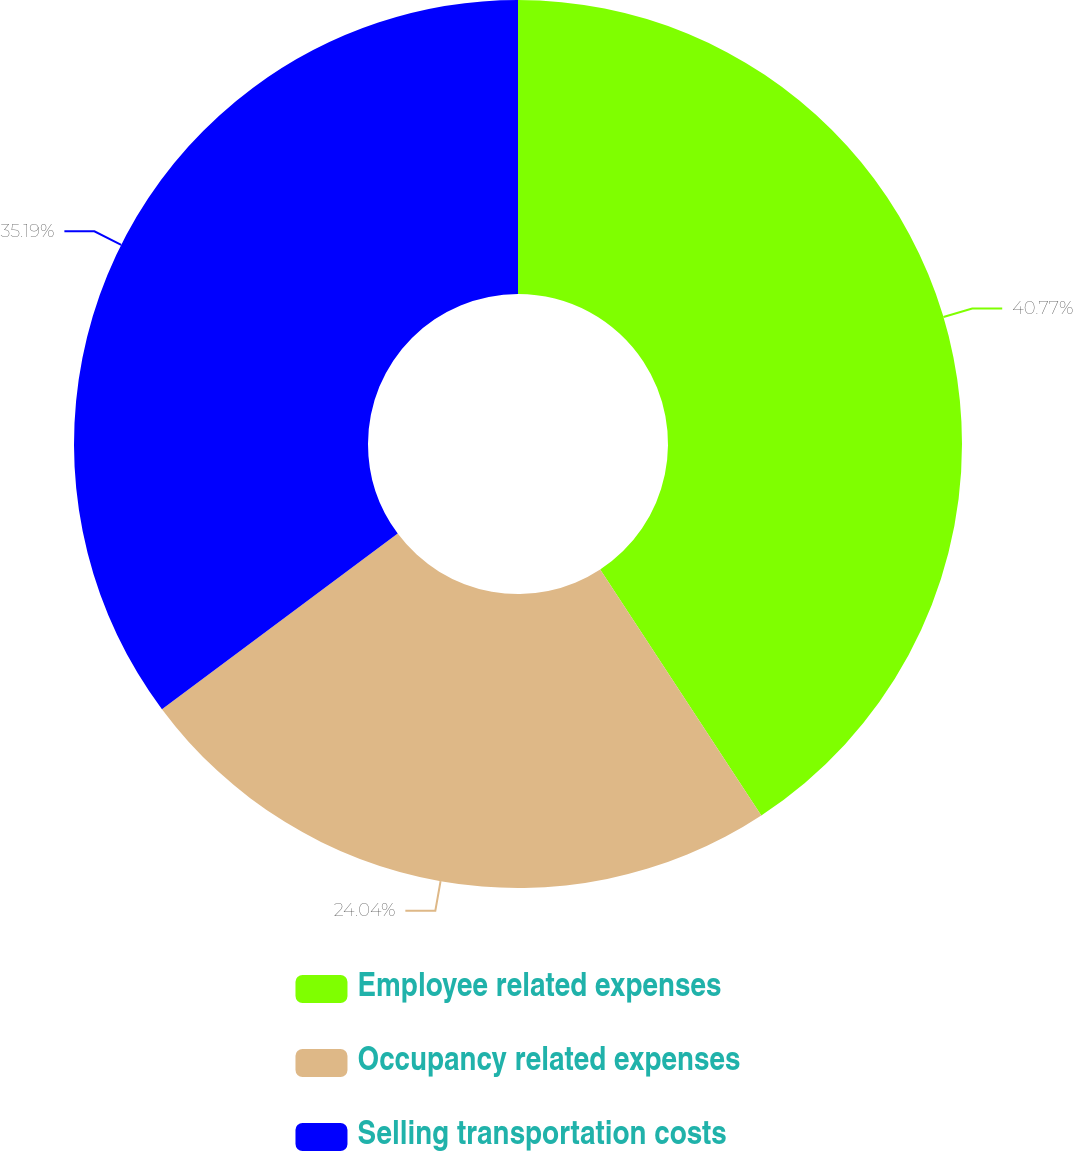<chart> <loc_0><loc_0><loc_500><loc_500><pie_chart><fcel>Employee related expenses<fcel>Occupancy related expenses<fcel>Selling transportation costs<nl><fcel>40.77%<fcel>24.04%<fcel>35.19%<nl></chart> 